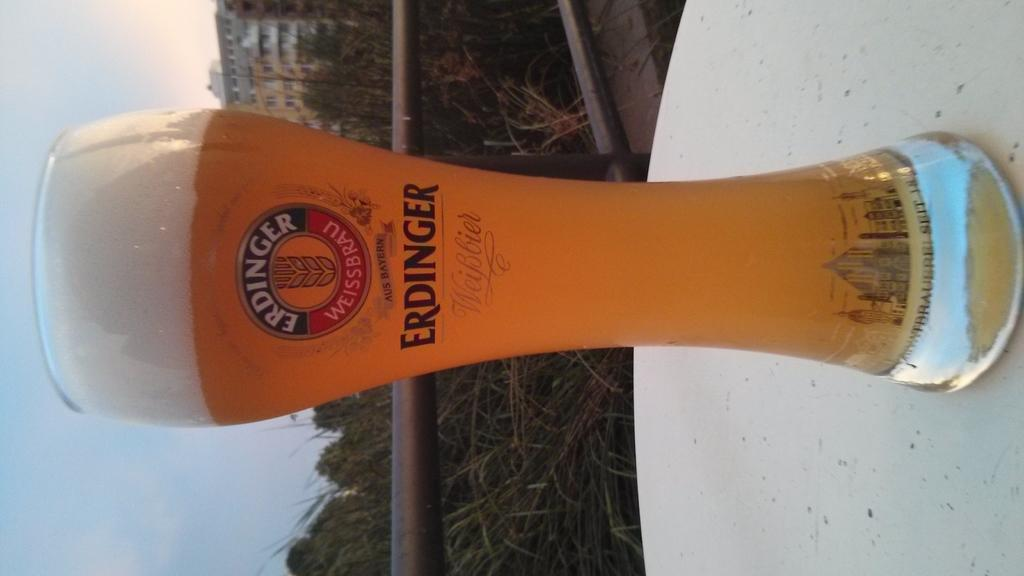What is on the table in the image? There is a glass of beer on a table in the image. What type of vegetation can be seen in the image? There are trees in the image. What type of structure is visible in the image? There is a building in the image. What is visible in the background of the image? The sky is visible in the background of the image. Can you tell me how many grapes are on the table in the image? There are no grapes present on the table in the image; only a glass of beer is visible. Is there a goose walking around in the image? There is no goose present in the image. 